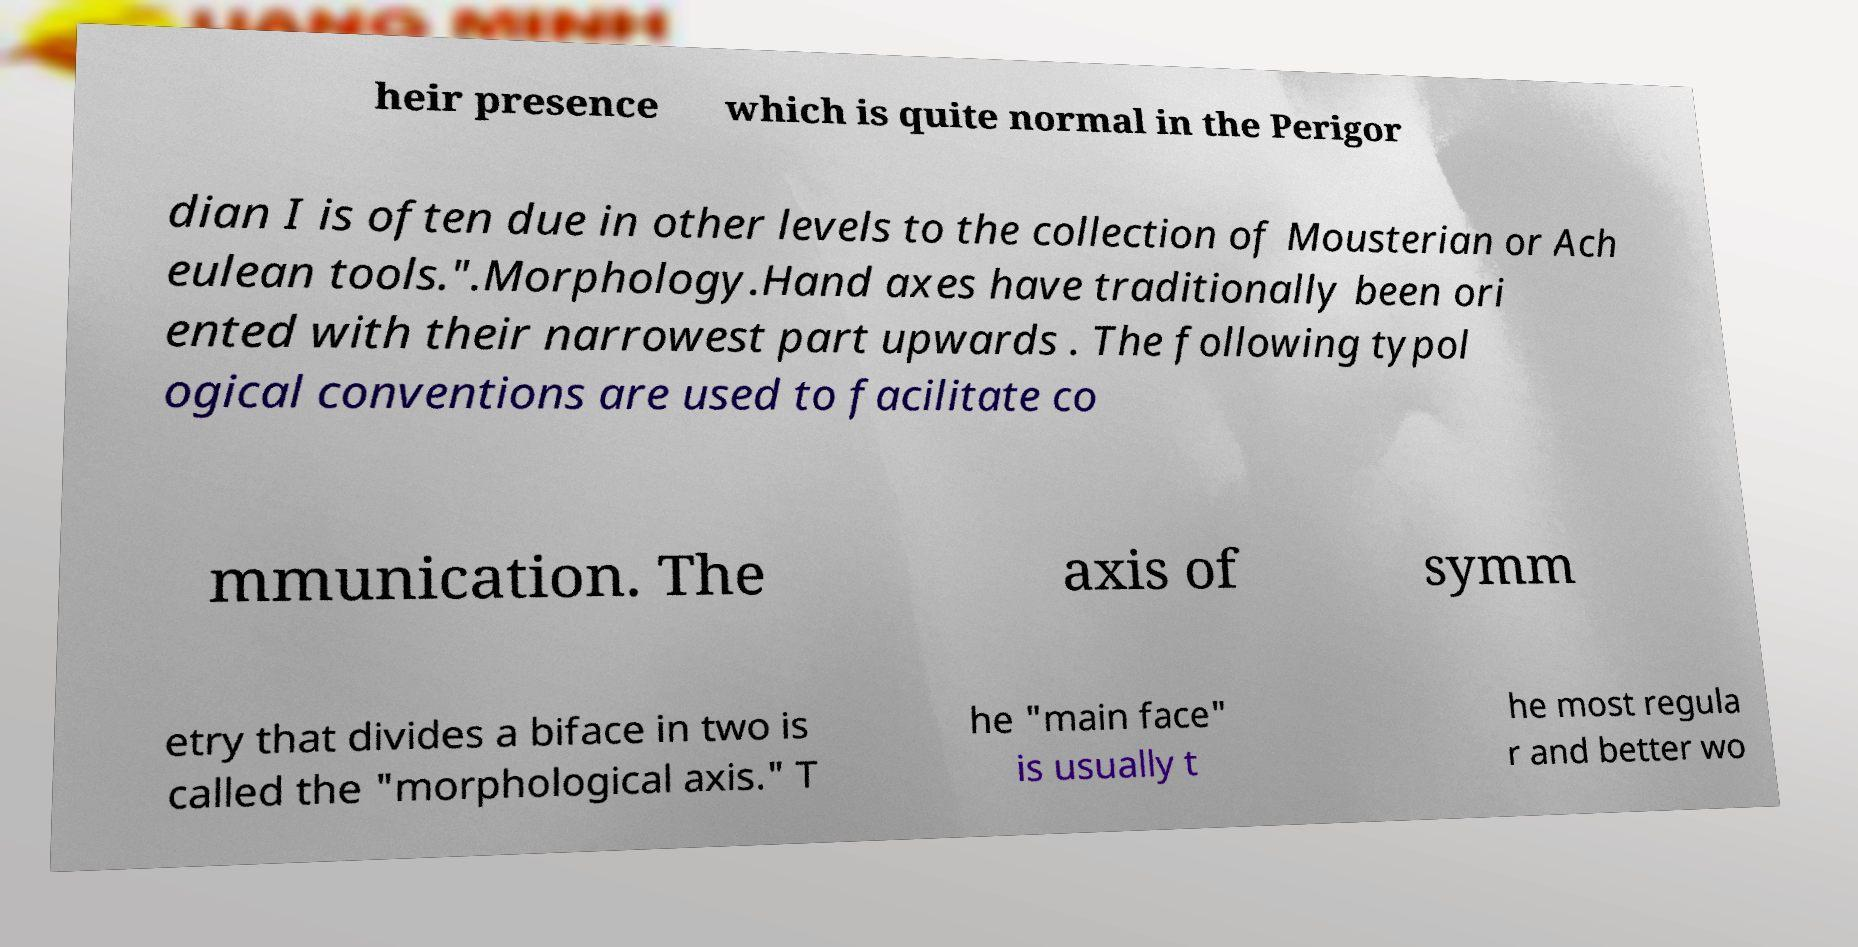Can you accurately transcribe the text from the provided image for me? heir presence which is quite normal in the Perigor dian I is often due in other levels to the collection of Mousterian or Ach eulean tools.".Morphology.Hand axes have traditionally been ori ented with their narrowest part upwards . The following typol ogical conventions are used to facilitate co mmunication. The axis of symm etry that divides a biface in two is called the "morphological axis." T he "main face" is usually t he most regula r and better wo 